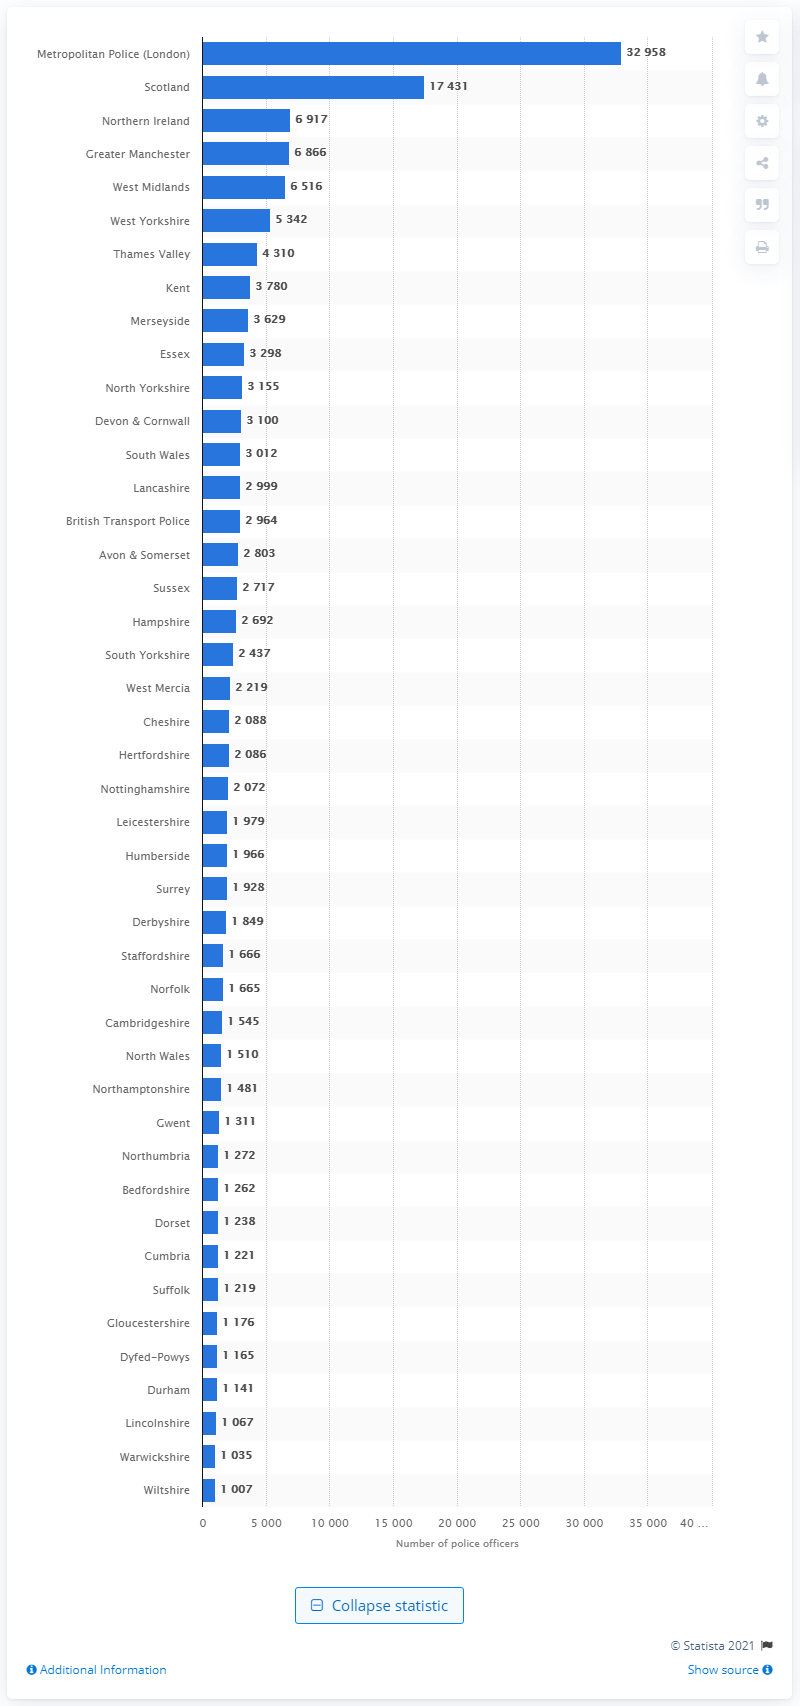Identify some key points in this picture. As of 2021, there are 17,431 officers serving in Scotland's Metropolitan Police force. As of 2020, London's Metropolitan Police had a total of 32,958 officers on their force. 